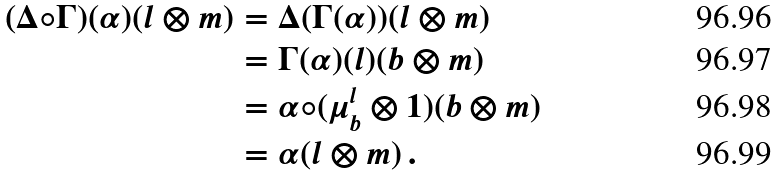Convert formula to latex. <formula><loc_0><loc_0><loc_500><loc_500>( \Delta \circ \Gamma ) ( \alpha ) ( l \otimes m ) & = \Delta ( \Gamma ( \alpha ) ) ( l \otimes m ) \\ & = \Gamma ( \alpha ) ( l ) ( b \otimes m ) \\ & = \alpha \circ ( \mu _ { b } ^ { l } \otimes 1 ) ( b \otimes m ) \\ & = \alpha ( l \otimes m ) \, .</formula> 